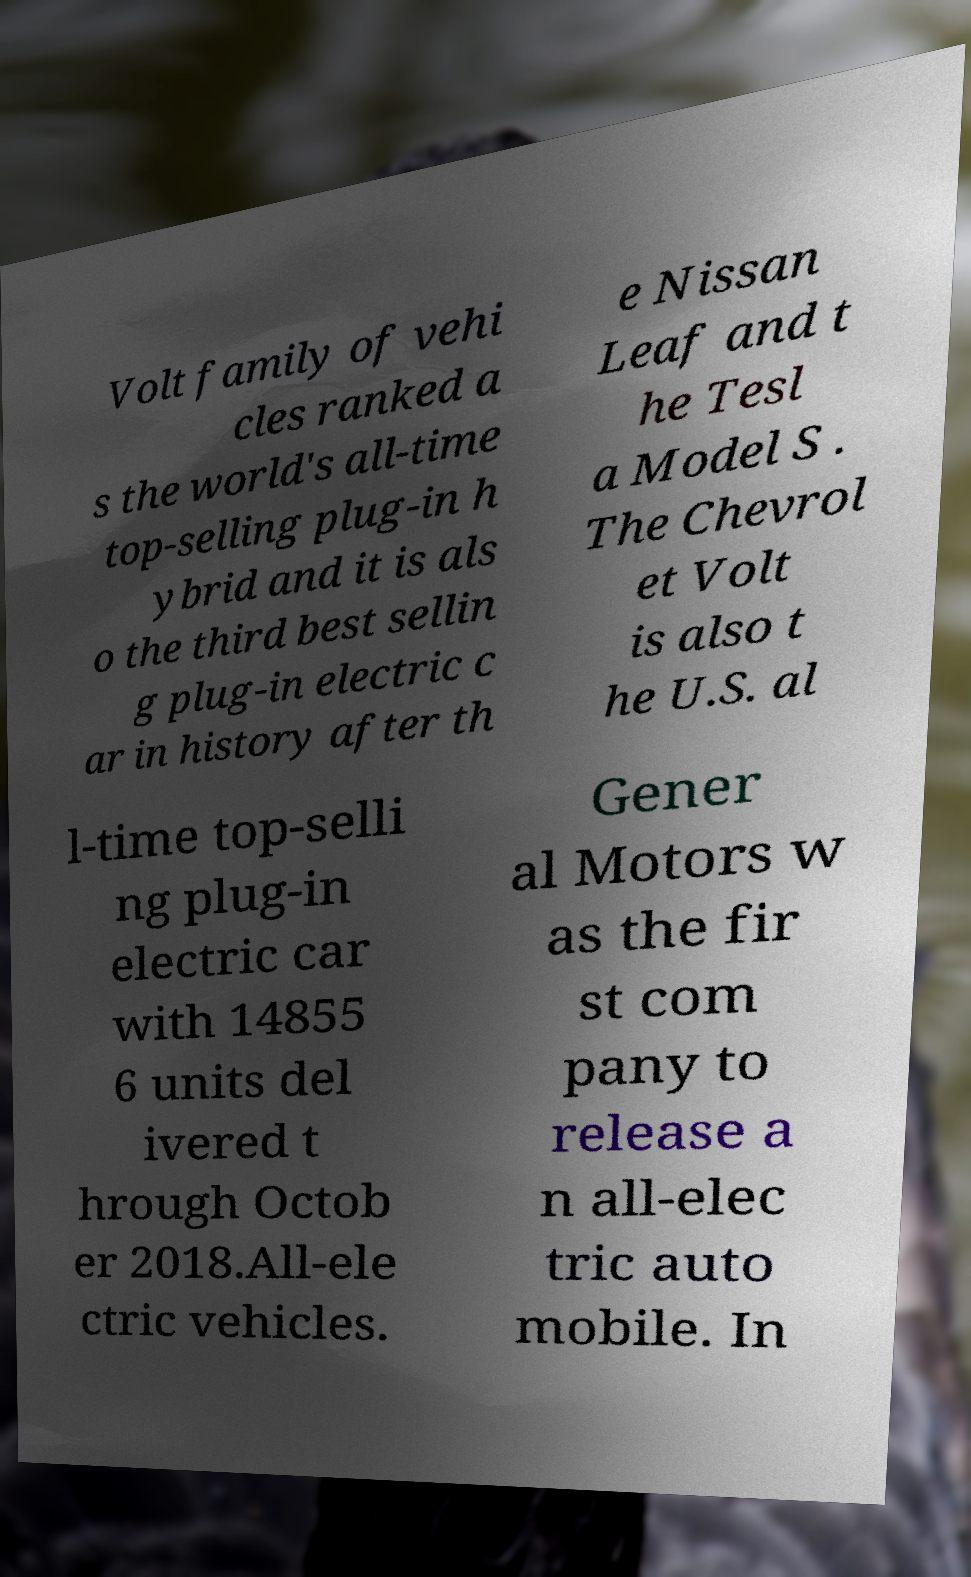Can you read and provide the text displayed in the image?This photo seems to have some interesting text. Can you extract and type it out for me? Volt family of vehi cles ranked a s the world's all-time top-selling plug-in h ybrid and it is als o the third best sellin g plug-in electric c ar in history after th e Nissan Leaf and t he Tesl a Model S . The Chevrol et Volt is also t he U.S. al l-time top-selli ng plug-in electric car with 14855 6 units del ivered t hrough Octob er 2018.All-ele ctric vehicles. Gener al Motors w as the fir st com pany to release a n all-elec tric auto mobile. In 